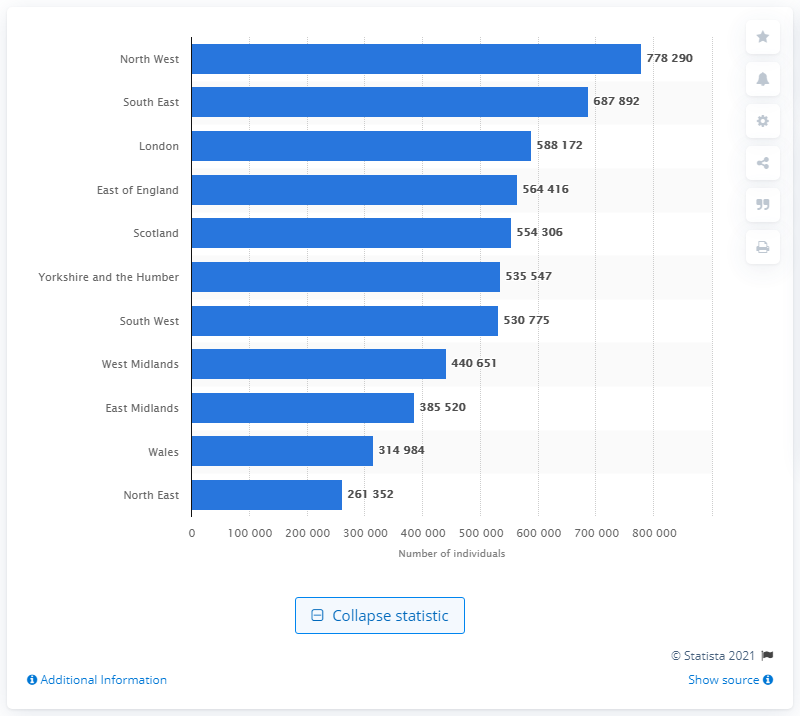How many people in the South East had asthma in 2015? In 2015, the South East recorded a total of 687,892 individuals living with asthma, as illustrated by the bar chart. 